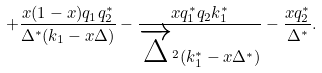<formula> <loc_0><loc_0><loc_500><loc_500>+ \frac { x ( 1 - x ) q _ { 1 } q _ { 2 } ^ { * } } { \Delta ^ { * } ( k _ { 1 } - x \Delta ) } - \frac { x q _ { 1 } ^ { * } q _ { 2 } k _ { 1 } ^ { * } } { \overrightarrow { \Delta } ^ { 2 } ( k _ { 1 } ^ { * } - x \Delta ^ { * } ) } - \frac { x q _ { 2 } ^ { * } } { \Delta ^ { * } } .</formula> 